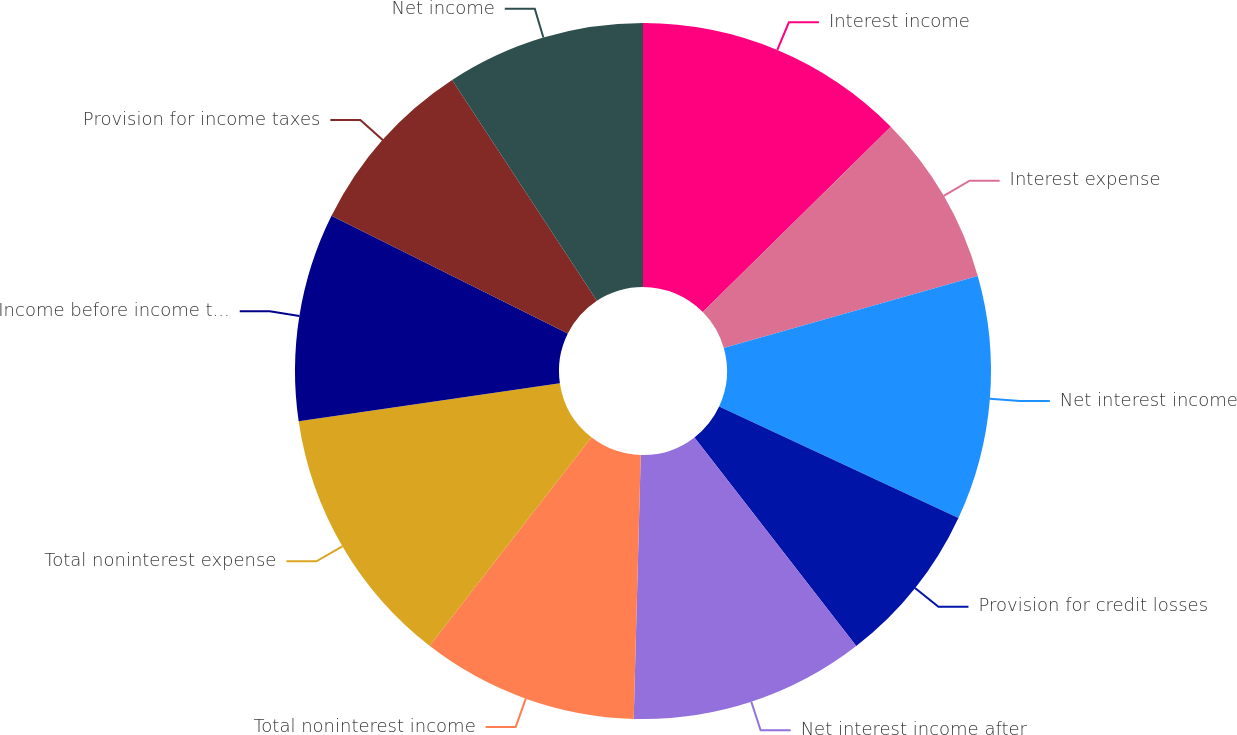<chart> <loc_0><loc_0><loc_500><loc_500><pie_chart><fcel>Interest income<fcel>Interest expense<fcel>Net interest income<fcel>Provision for credit losses<fcel>Net interest income after<fcel>Total noninterest income<fcel>Total noninterest expense<fcel>Income before income taxes<fcel>Provision for income taxes<fcel>Net income<nl><fcel>12.61%<fcel>7.98%<fcel>11.34%<fcel>7.56%<fcel>10.92%<fcel>10.08%<fcel>12.18%<fcel>9.66%<fcel>8.4%<fcel>9.24%<nl></chart> 